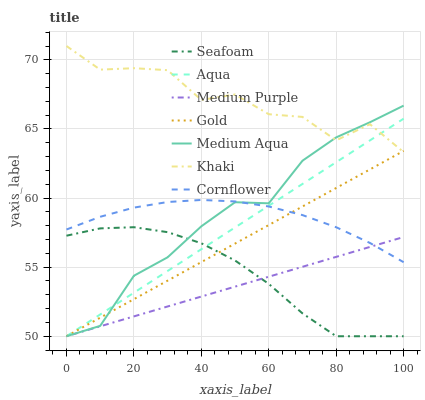Does Medium Purple have the minimum area under the curve?
Answer yes or no. Yes. Does Khaki have the maximum area under the curve?
Answer yes or no. Yes. Does Gold have the minimum area under the curve?
Answer yes or no. No. Does Gold have the maximum area under the curve?
Answer yes or no. No. Is Aqua the smoothest?
Answer yes or no. Yes. Is Khaki the roughest?
Answer yes or no. Yes. Is Gold the smoothest?
Answer yes or no. No. Is Gold the roughest?
Answer yes or no. No. Does Gold have the lowest value?
Answer yes or no. Yes. Does Khaki have the lowest value?
Answer yes or no. No. Does Khaki have the highest value?
Answer yes or no. Yes. Does Gold have the highest value?
Answer yes or no. No. Is Seafoam less than Cornflower?
Answer yes or no. Yes. Is Khaki greater than Cornflower?
Answer yes or no. Yes. Does Medium Purple intersect Medium Aqua?
Answer yes or no. Yes. Is Medium Purple less than Medium Aqua?
Answer yes or no. No. Is Medium Purple greater than Medium Aqua?
Answer yes or no. No. Does Seafoam intersect Cornflower?
Answer yes or no. No. 